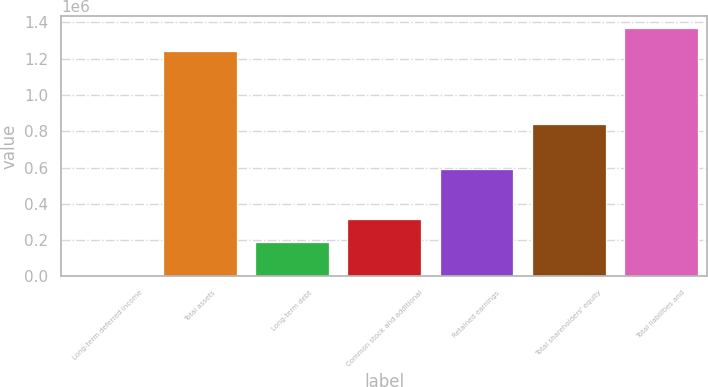Convert chart to OTSL. <chart><loc_0><loc_0><loc_500><loc_500><bar_chart><fcel>Long-term deferred income<fcel>Total assets<fcel>Long-term debt<fcel>Common stock and additional<fcel>Retained earnings<fcel>Total shareholders' equity<fcel>Total liabilities and<nl><fcel>5047<fcel>1.24391e+06<fcel>190318<fcel>314204<fcel>592766<fcel>840062<fcel>1.36779e+06<nl></chart> 